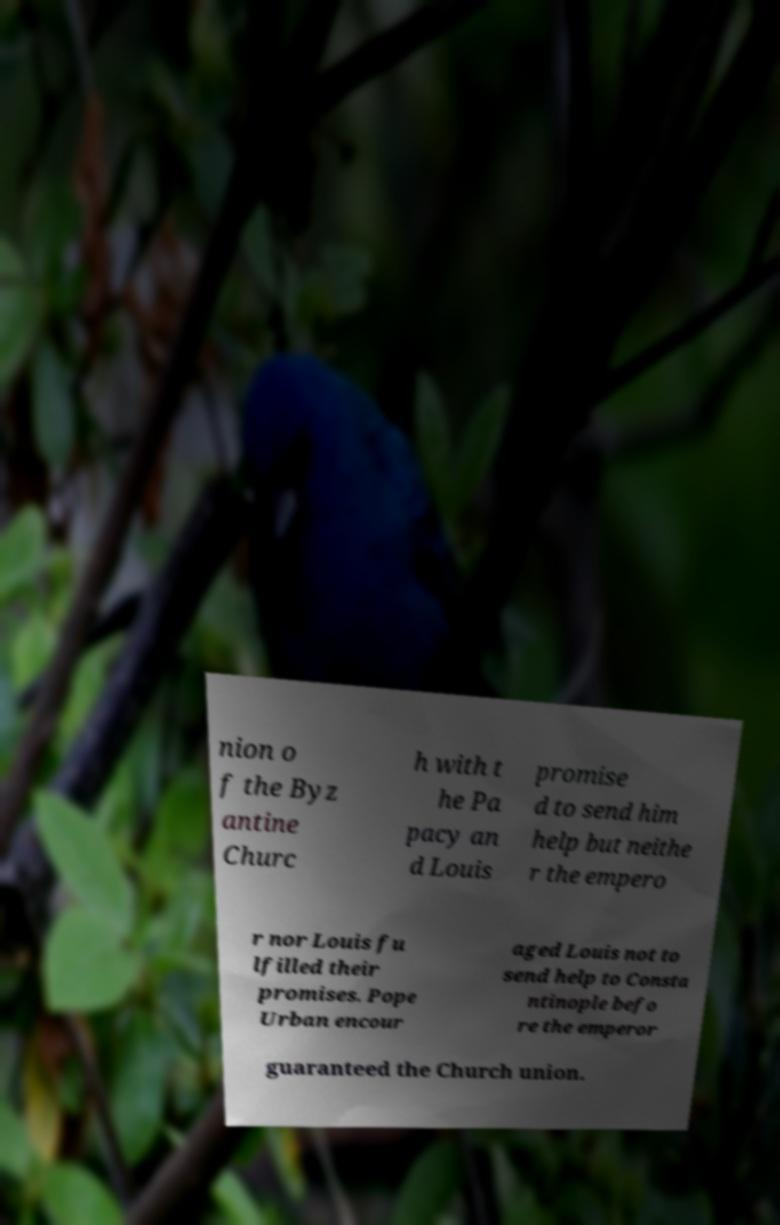Can you read and provide the text displayed in the image?This photo seems to have some interesting text. Can you extract and type it out for me? nion o f the Byz antine Churc h with t he Pa pacy an d Louis promise d to send him help but neithe r the empero r nor Louis fu lfilled their promises. Pope Urban encour aged Louis not to send help to Consta ntinople befo re the emperor guaranteed the Church union. 